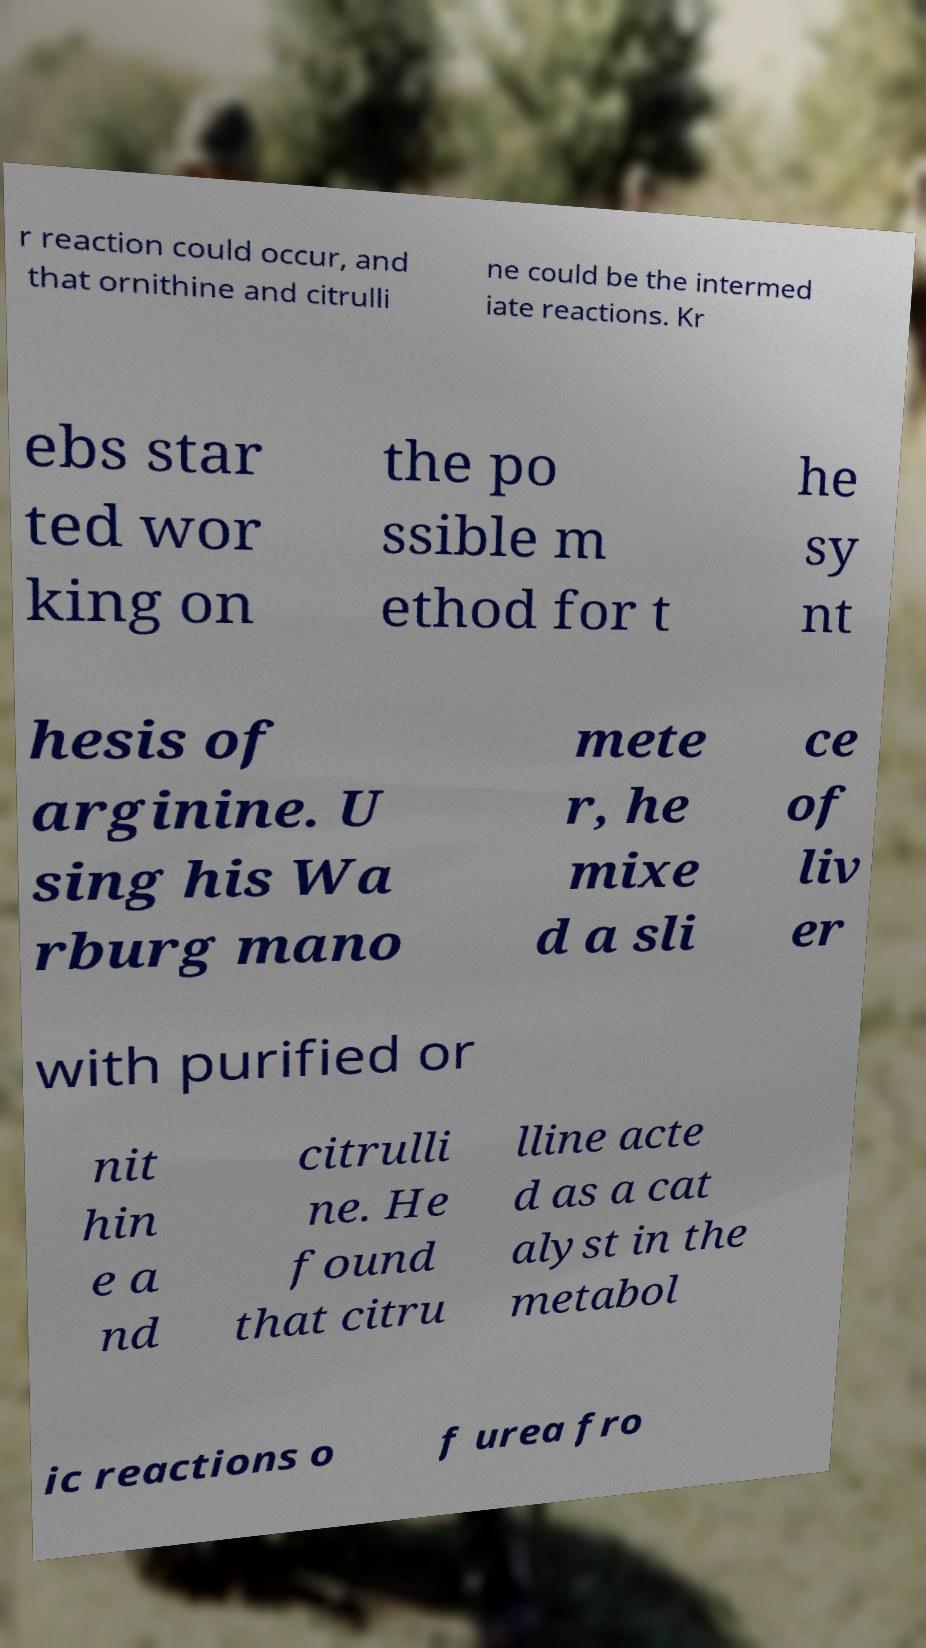Could you extract and type out the text from this image? r reaction could occur, and that ornithine and citrulli ne could be the intermed iate reactions. Kr ebs star ted wor king on the po ssible m ethod for t he sy nt hesis of arginine. U sing his Wa rburg mano mete r, he mixe d a sli ce of liv er with purified or nit hin e a nd citrulli ne. He found that citru lline acte d as a cat alyst in the metabol ic reactions o f urea fro 